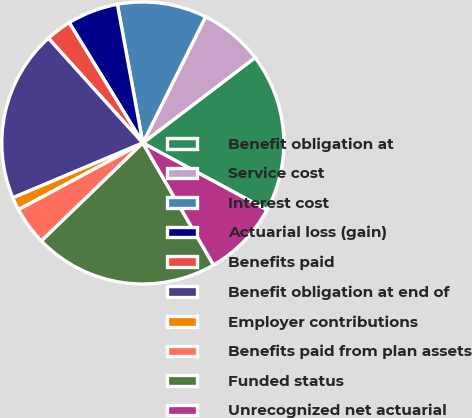Convert chart to OTSL. <chart><loc_0><loc_0><loc_500><loc_500><pie_chart><fcel>Benefit obligation at<fcel>Service cost<fcel>Interest cost<fcel>Actuarial loss (gain)<fcel>Benefits paid<fcel>Benefit obligation at end of<fcel>Employer contributions<fcel>Benefits paid from plan assets<fcel>Funded status<fcel>Unrecognized net actuarial<nl><fcel>18.22%<fcel>7.31%<fcel>10.23%<fcel>5.85%<fcel>2.94%<fcel>19.68%<fcel>1.48%<fcel>4.4%<fcel>21.13%<fcel>8.77%<nl></chart> 